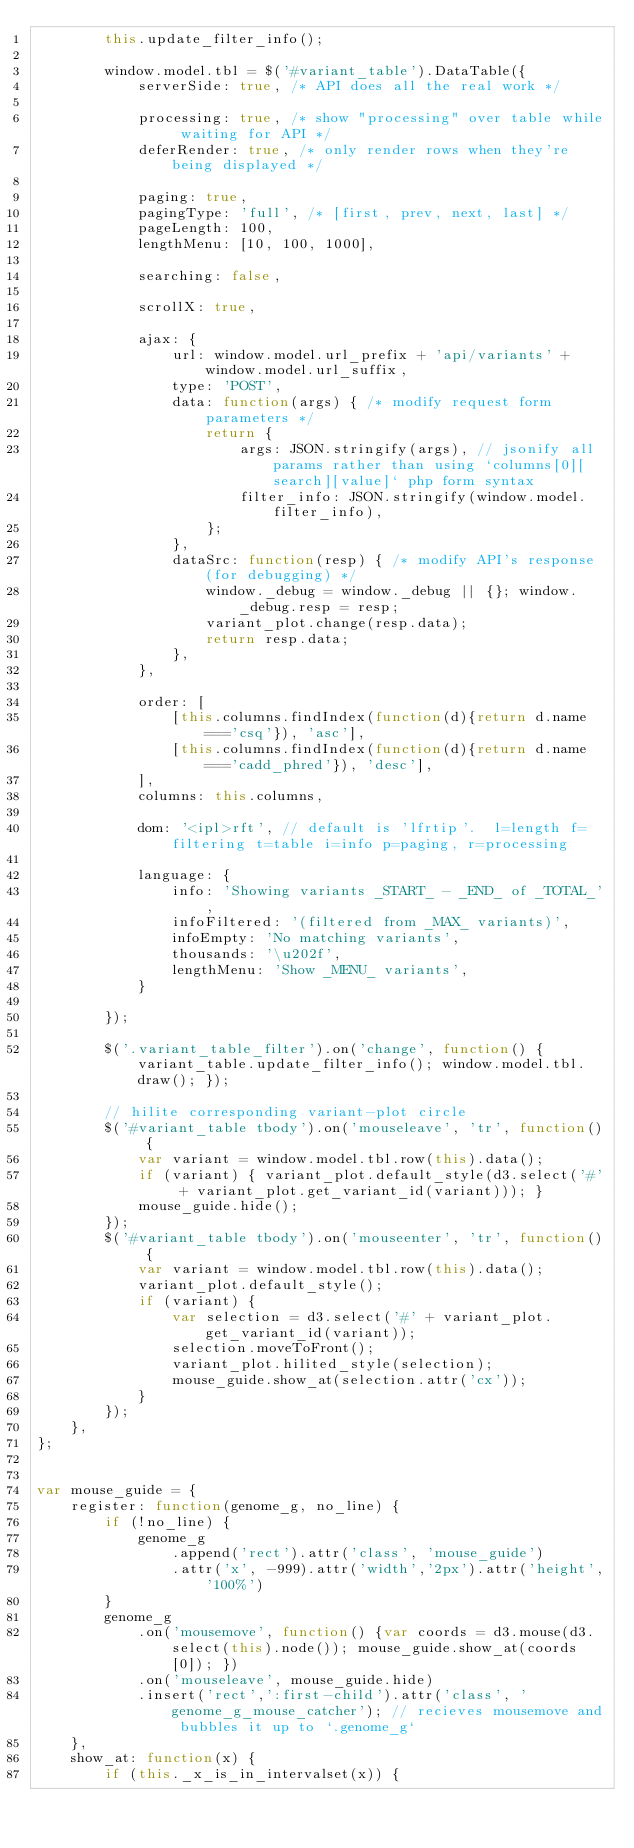Convert code to text. <code><loc_0><loc_0><loc_500><loc_500><_JavaScript_>        this.update_filter_info();

        window.model.tbl = $('#variant_table').DataTable({
            serverSide: true, /* API does all the real work */

            processing: true, /* show "processing" over table while waiting for API */
            deferRender: true, /* only render rows when they're being displayed */

            paging: true,
            pagingType: 'full', /* [first, prev, next, last] */
            pageLength: 100,
            lengthMenu: [10, 100, 1000],

            searching: false,

            scrollX: true,

            ajax: {
                url: window.model.url_prefix + 'api/variants' + window.model.url_suffix,
                type: 'POST',
                data: function(args) { /* modify request form parameters */
                    return {
                        args: JSON.stringify(args), // jsonify all params rather than using `columns[0][search][value]` php form syntax
                        filter_info: JSON.stringify(window.model.filter_info),
                    };
                },
                dataSrc: function(resp) { /* modify API's response (for debugging) */
                    window._debug = window._debug || {}; window._debug.resp = resp;
                    variant_plot.change(resp.data);
                    return resp.data;
                },
            },

            order: [
                [this.columns.findIndex(function(d){return d.name==='csq'}), 'asc'],
                [this.columns.findIndex(function(d){return d.name==='cadd_phred'}), 'desc'],
            ],
            columns: this.columns,

            dom: '<ipl>rft', // default is 'lfrtip'.  l=length f=filtering t=table i=info p=paging, r=processing

            language: {
                info: 'Showing variants _START_ - _END_ of _TOTAL_',
                infoFiltered: '(filtered from _MAX_ variants)',
                infoEmpty: 'No matching variants',
                thousands: '\u202f',
                lengthMenu: 'Show _MENU_ variants',
            }

        });

        $('.variant_table_filter').on('change', function() { variant_table.update_filter_info(); window.model.tbl.draw(); });

        // hilite corresponding variant-plot circle
        $('#variant_table tbody').on('mouseleave', 'tr', function() {
            var variant = window.model.tbl.row(this).data();
            if (variant) { variant_plot.default_style(d3.select('#' + variant_plot.get_variant_id(variant))); }
            mouse_guide.hide();
        });
        $('#variant_table tbody').on('mouseenter', 'tr', function() {
            var variant = window.model.tbl.row(this).data();
            variant_plot.default_style();
            if (variant) {
                var selection = d3.select('#' + variant_plot.get_variant_id(variant));
                selection.moveToFront();
                variant_plot.hilited_style(selection);
                mouse_guide.show_at(selection.attr('cx'));
            }
        });
    },
};


var mouse_guide = {
    register: function(genome_g, no_line) {
        if (!no_line) {
            genome_g
                .append('rect').attr('class', 'mouse_guide')
                .attr('x', -999).attr('width','2px').attr('height','100%')
        }
        genome_g
            .on('mousemove', function() {var coords = d3.mouse(d3.select(this).node()); mouse_guide.show_at(coords[0]); })
            .on('mouseleave', mouse_guide.hide)
            .insert('rect',':first-child').attr('class', 'genome_g_mouse_catcher'); // recieves mousemove and bubbles it up to `.genome_g`
    },
    show_at: function(x) {
        if (this._x_is_in_intervalset(x)) {</code> 